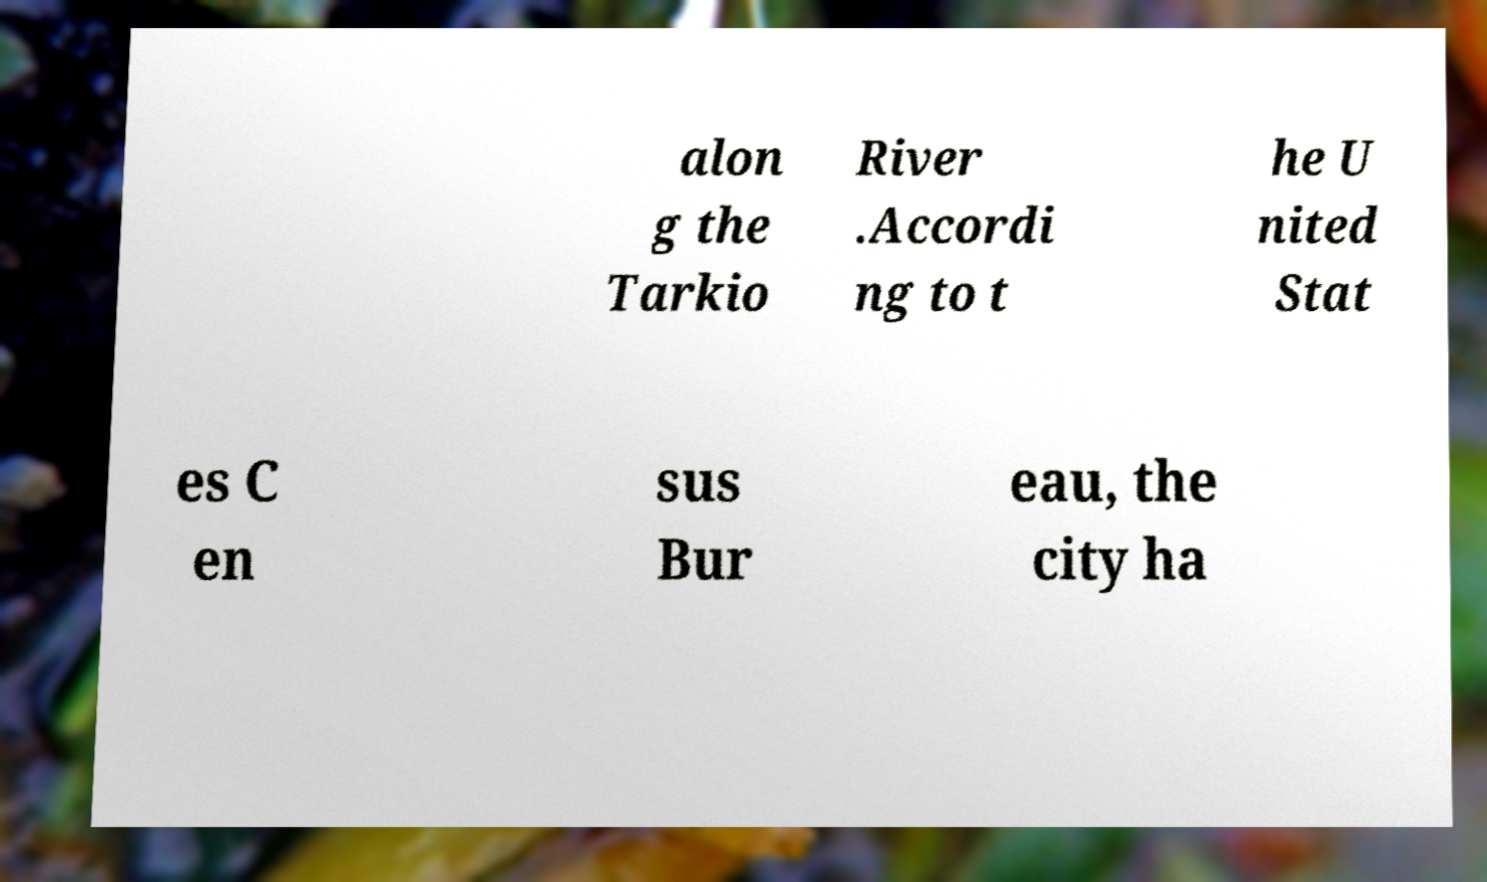For documentation purposes, I need the text within this image transcribed. Could you provide that? alon g the Tarkio River .Accordi ng to t he U nited Stat es C en sus Bur eau, the city ha 